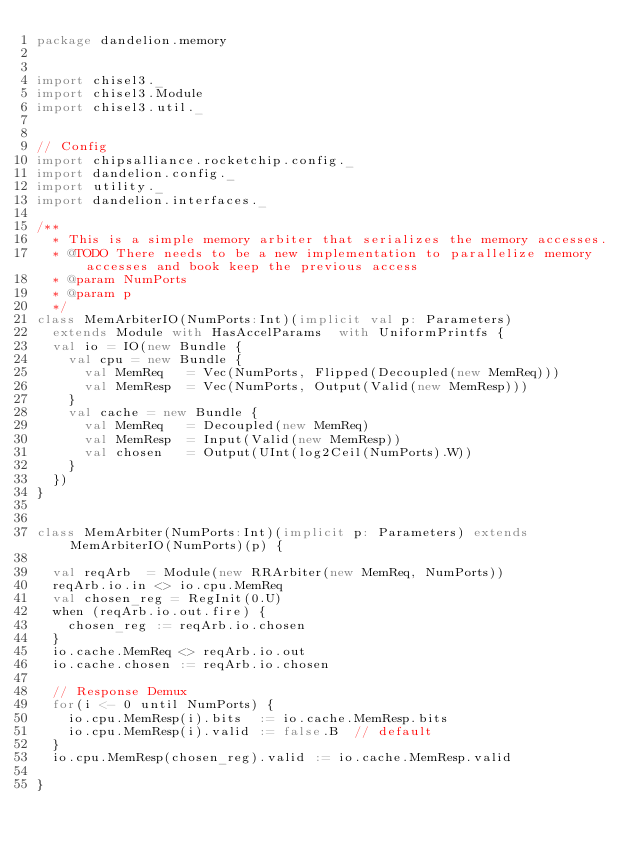<code> <loc_0><loc_0><loc_500><loc_500><_Scala_>package dandelion.memory


import chisel3._
import chisel3.Module
import chisel3.util._


// Config
import chipsalliance.rocketchip.config._
import dandelion.config._
import utility._
import dandelion.interfaces._

/**
  * This is a simple memory arbiter that serializes the memory accesses.
  * @TODO There needs to be a new implementation to parallelize memory accesses and book keep the previous access
  * @param NumPorts
  * @param p
  */
class MemArbiterIO(NumPorts:Int)(implicit val p: Parameters)
  extends Module with HasAccelParams  with UniformPrintfs {
  val io = IO(new Bundle {
    val cpu = new Bundle {
      val MemReq   = Vec(NumPorts, Flipped(Decoupled(new MemReq)))
      val MemResp  = Vec(NumPorts, Output(Valid(new MemResp)))
    }
    val cache = new Bundle {
      val MemReq   = Decoupled(new MemReq)
      val MemResp  = Input(Valid(new MemResp))
      val chosen   = Output(UInt(log2Ceil(NumPorts).W))
    }
  })
}


class MemArbiter(NumPorts:Int)(implicit p: Parameters) extends MemArbiterIO(NumPorts)(p) {

  val reqArb  = Module(new RRArbiter(new MemReq, NumPorts))
  reqArb.io.in <> io.cpu.MemReq
  val chosen_reg = RegInit(0.U)
  when (reqArb.io.out.fire) {
    chosen_reg := reqArb.io.chosen
  }
  io.cache.MemReq <> reqArb.io.out
  io.cache.chosen := reqArb.io.chosen

  // Response Demux
  for(i <- 0 until NumPorts) {
    io.cpu.MemResp(i).bits  := io.cache.MemResp.bits
    io.cpu.MemResp(i).valid := false.B  // default
  }
  io.cpu.MemResp(chosen_reg).valid := io.cache.MemResp.valid

}
</code> 